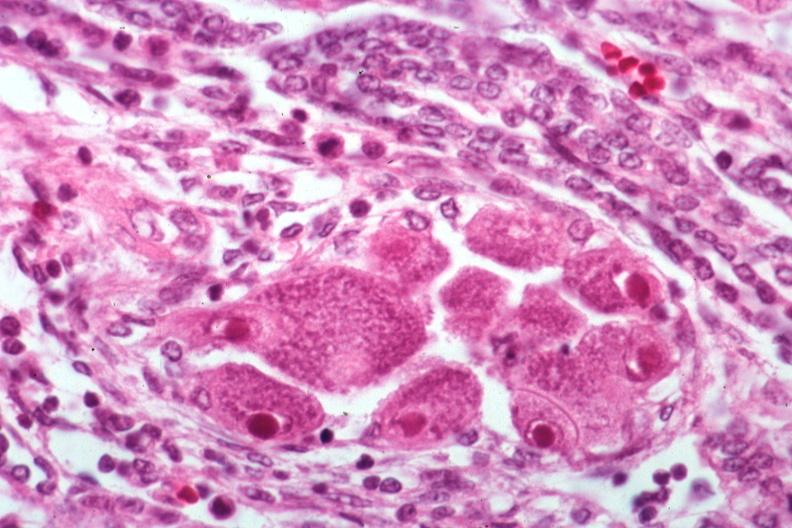s kidney present?
Answer the question using a single word or phrase. Yes 